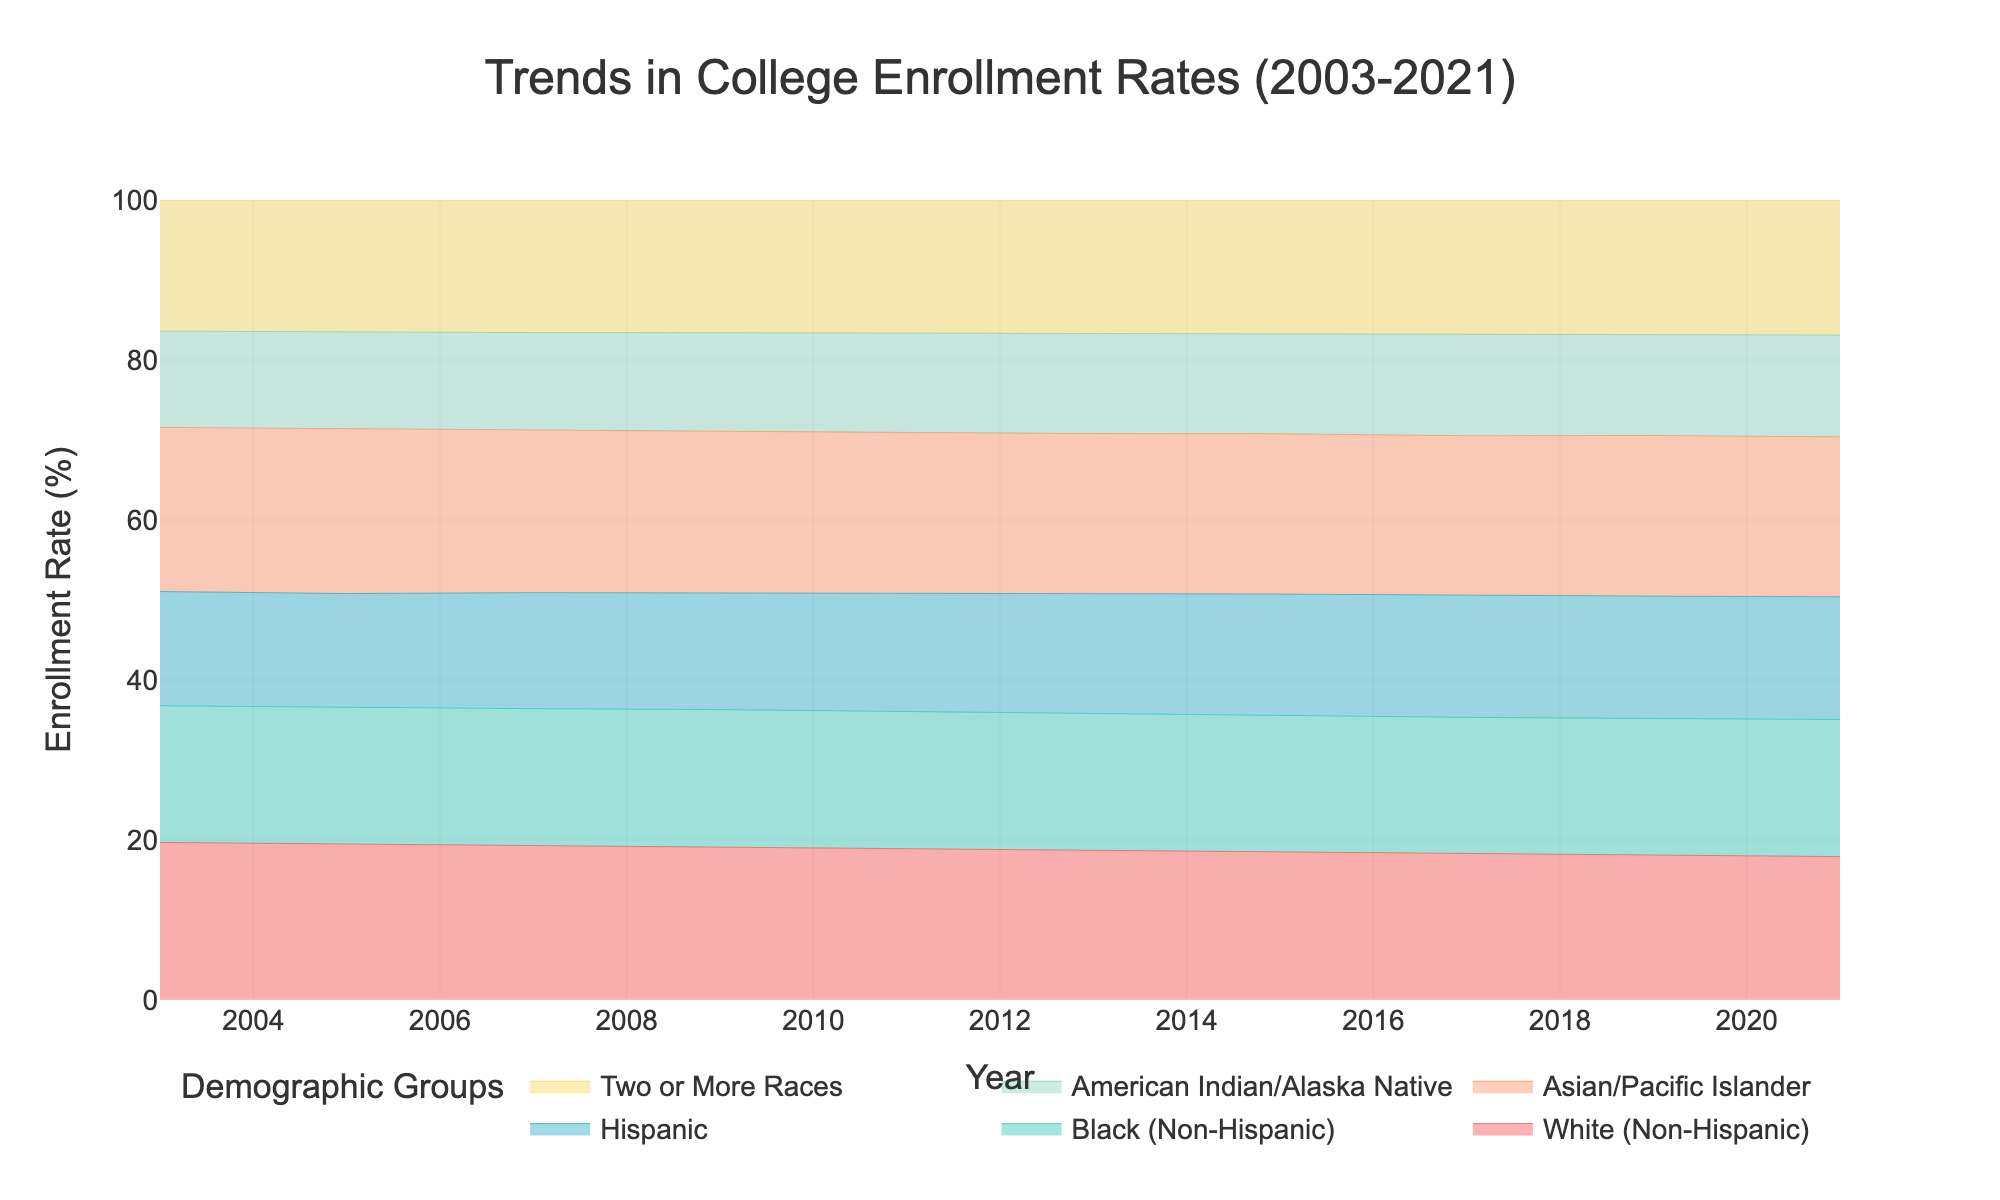What is the title of the chart? The title is usually located at the top of the chart. In this case, it clearly states "Trends in College Enrollment Rates (2003-2021)"
Answer: Trends in College Enrollment Rates (2003-2021) What is the enrollment rate for Hispanic students in 2015? Look at the point for Hispanic students along the year 2015 line. The rate is labeled on the y-axis and is within the colored section corresponding to Hispanic students.
Answer: 55.5% Which demographic had the highest college enrollment rate in 2021? To find the demographic with the highest enrollment rate in 2021, look at the topmost line at the year 2021. This highest position indicates the demographic group with the highest rate.
Answer: Asian/Pacific Islander How did the college enrollment rate for Black (Non-Hispanic) students change from 2003 to 2021? Compare the Black (Non-Hispanic) group's enrollment rate in 2003 and 2021, reading the values off the y-axis for each corresponding year.
Answer: The rate increased from 54.2% in 2003 to 66.0% in 2021 Between which years did the American Indian/Alaska Native students see the most significant increase in enrollment rate? Examine the American Indian/Alaska Native group line, identifying the segment with the steepest incline over different periods.
Answer: Between 2009 and 2011 What was the enrollment rate of Two or More Races students in 2019? Locate the value for Two or More Races demographic in the year 2019, referring to the y-axis values aligned with that point.
Answer: 64.2% Compare the enrollment rates of White (Non-Hispanic) and Hispanic students in 2017. Which group had a higher rate and by how much? Identify the values for both demographic groups in 2017, then calculate the difference to determine which had the higher rate and the amount by which it was higher.
Answer: White (Non-Hispanic) had a higher rate by 11.5% (68.5% - 57.0%) Which demographic groups showed a continuous increase in enrollment rates from 2003 to 2021? Examine the trend lines for all demographic groups and identify those that show a continuous upward trend without any downward dips.
Answer: All groups How did the college enrollment rates for Asian/Pacific Islander students change overall from 2003 to 2021? Observe the rate for Asian/Pacific Islander students in 2003 and 2021 and note the difference to see how it changed.
Answer: The rate increased from 65.1% in 2003 to 77.0% in 2021 What is the difference in college enrollment rates for the group with the lowest increase versus the group with the highest increase from 2003 to 2021? Calculate the increase for all groups, then find the difference between the group with the largest increase and the one with the smallest increase over the given period.
Answer: Asian/Pacific Islander had the highest increase (77.0% - 65.1% = 11.9%), and American Indian/Alaska Native had the lowest increase (49.0% - 38.2% = 10.8%). The difference is 1.1% 